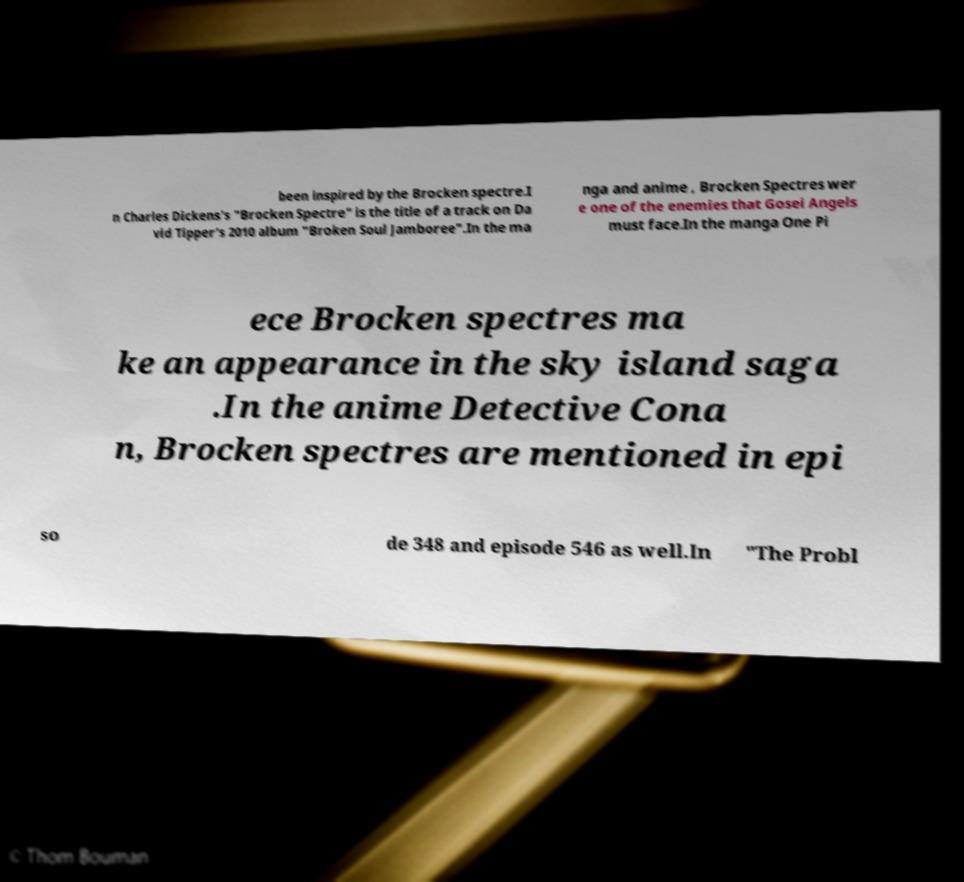Could you assist in decoding the text presented in this image and type it out clearly? been inspired by the Brocken spectre.I n Charles Dickens's "Brocken Spectre" is the title of a track on Da vid Tipper's 2010 album "Broken Soul Jamboree".In the ma nga and anime , Brocken Spectres wer e one of the enemies that Gosei Angels must face.In the manga One Pi ece Brocken spectres ma ke an appearance in the sky island saga .In the anime Detective Cona n, Brocken spectres are mentioned in epi so de 348 and episode 546 as well.In "The Probl 